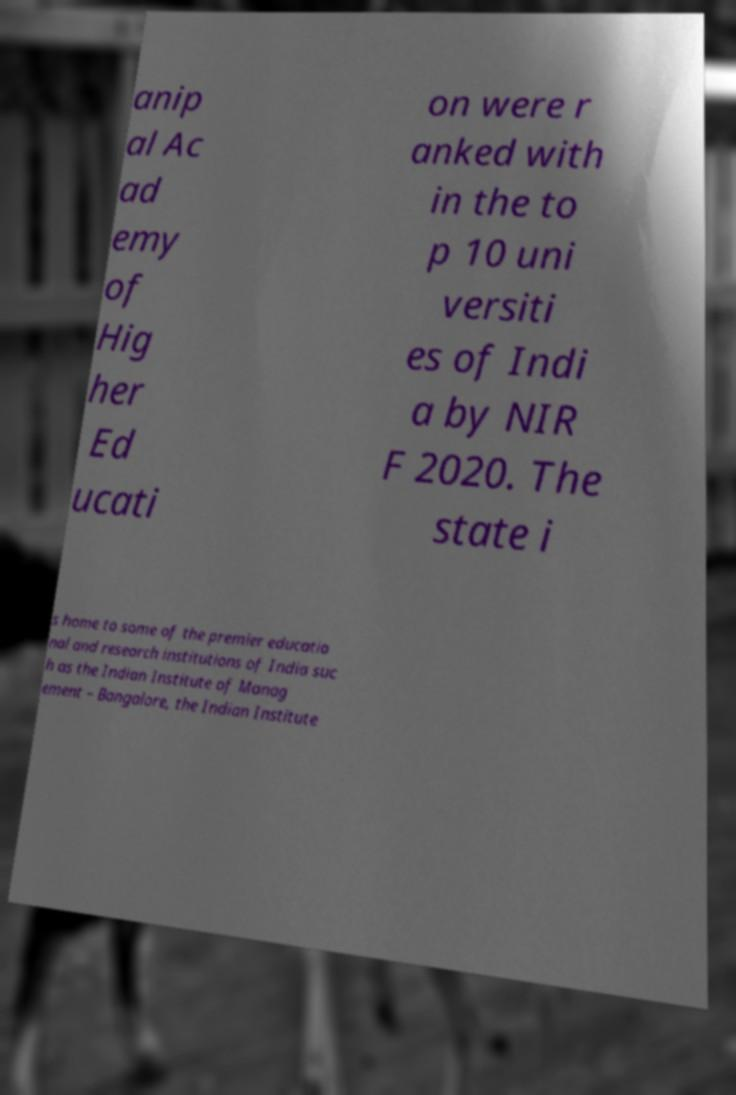Please identify and transcribe the text found in this image. anip al Ac ad emy of Hig her Ed ucati on were r anked with in the to p 10 uni versiti es of Indi a by NIR F 2020. The state i s home to some of the premier educatio nal and research institutions of India suc h as the Indian Institute of Manag ement – Bangalore, the Indian Institute 